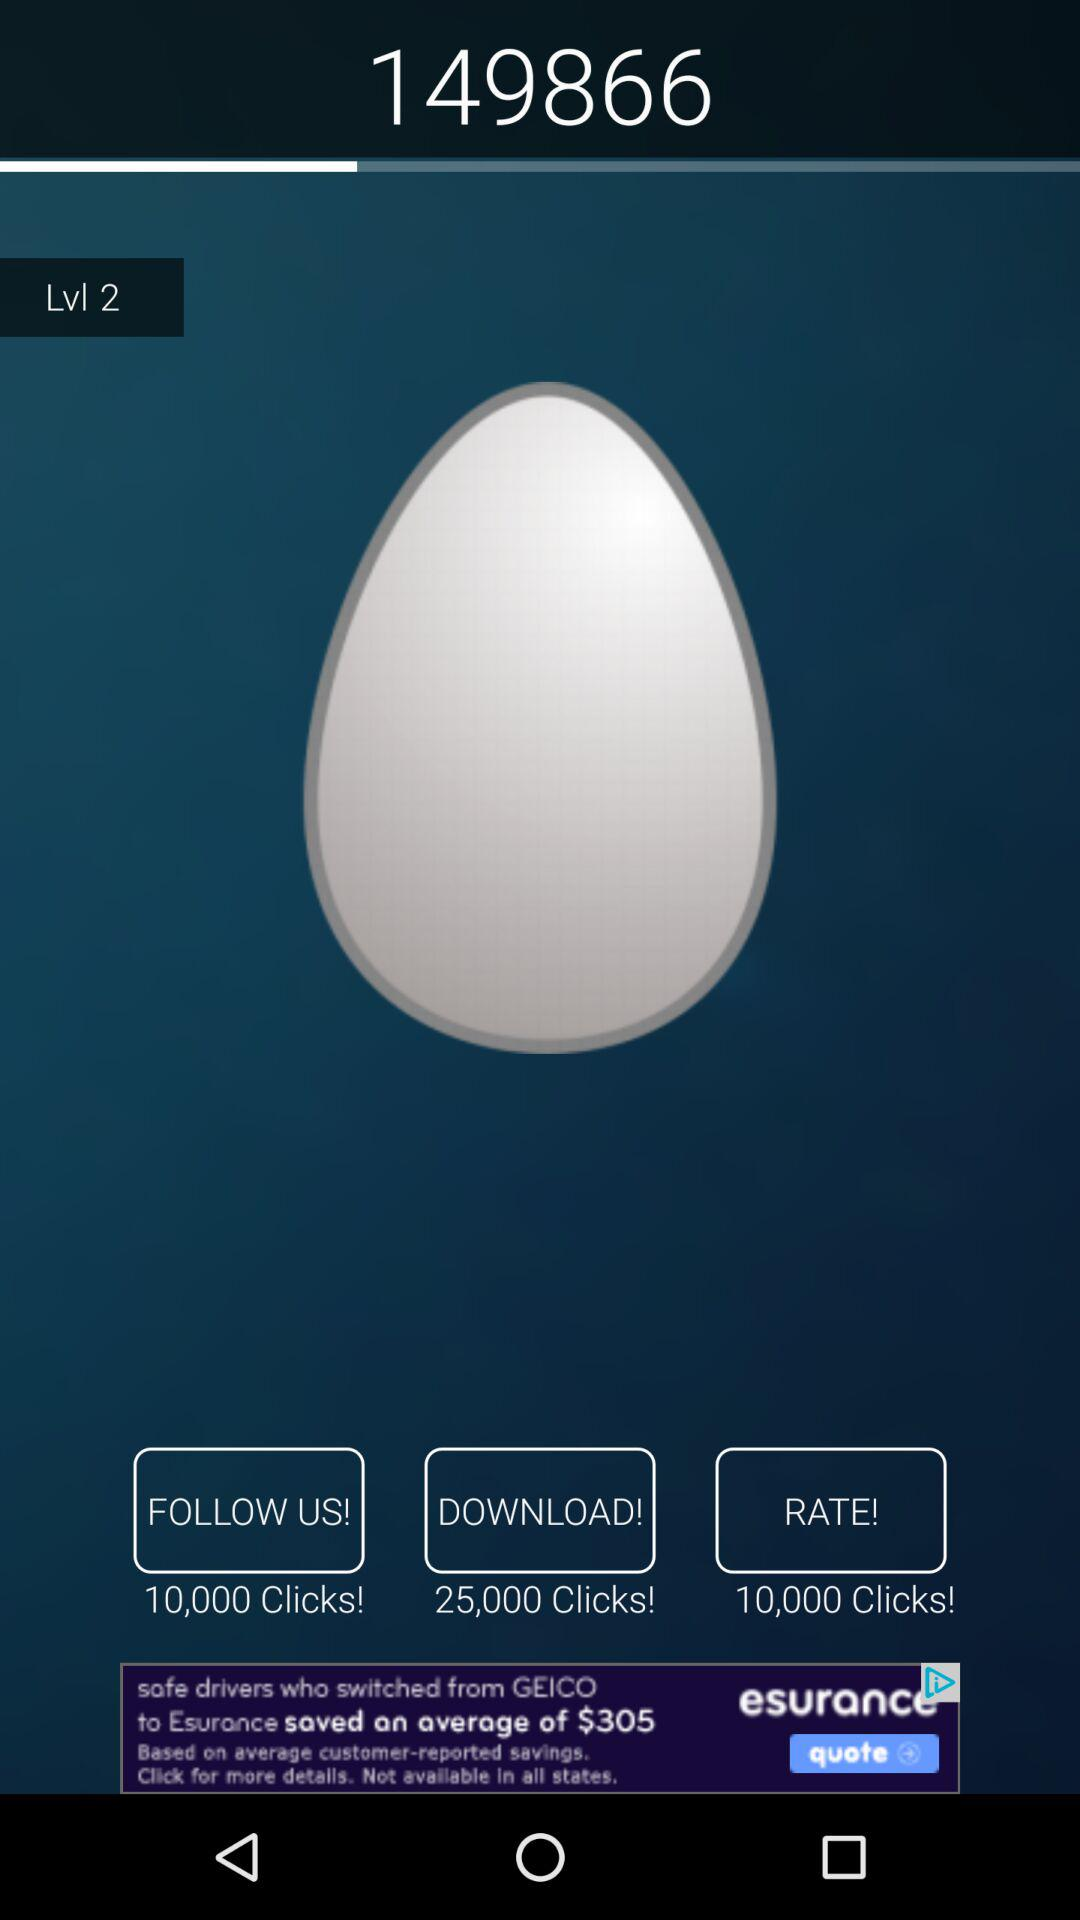What is the number in the top box? The number is 149866. 